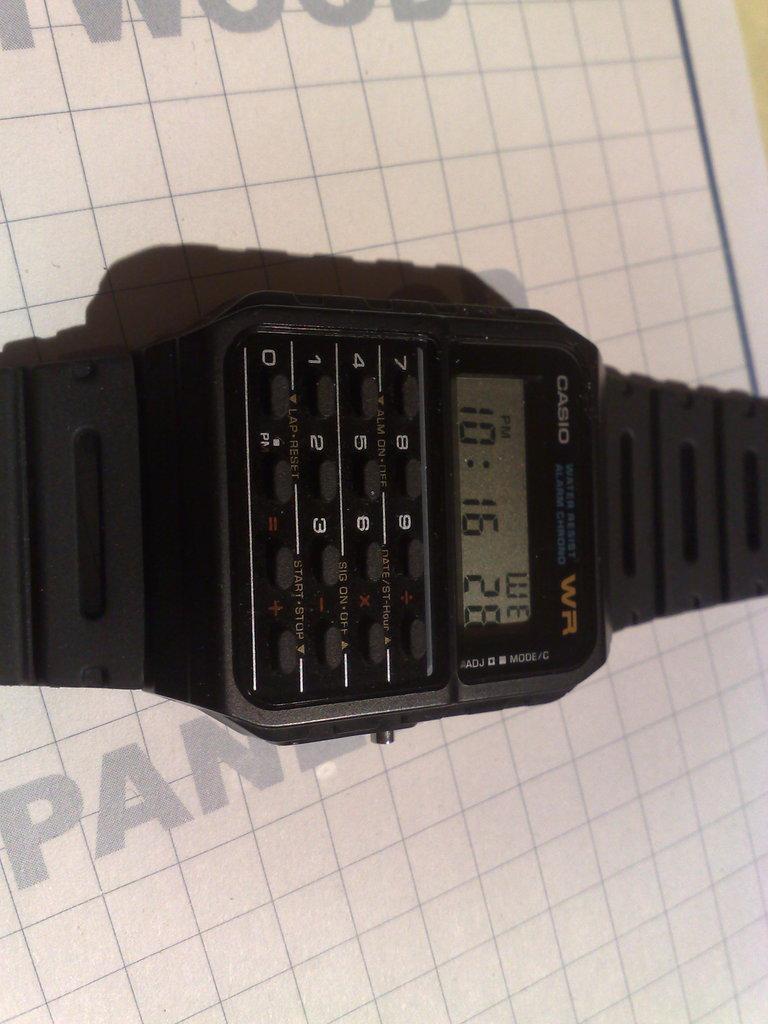Describe this image in one or two sentences. In this picture I can see there is a watch, it has buttons and a screen and it is placed on a white surface. 